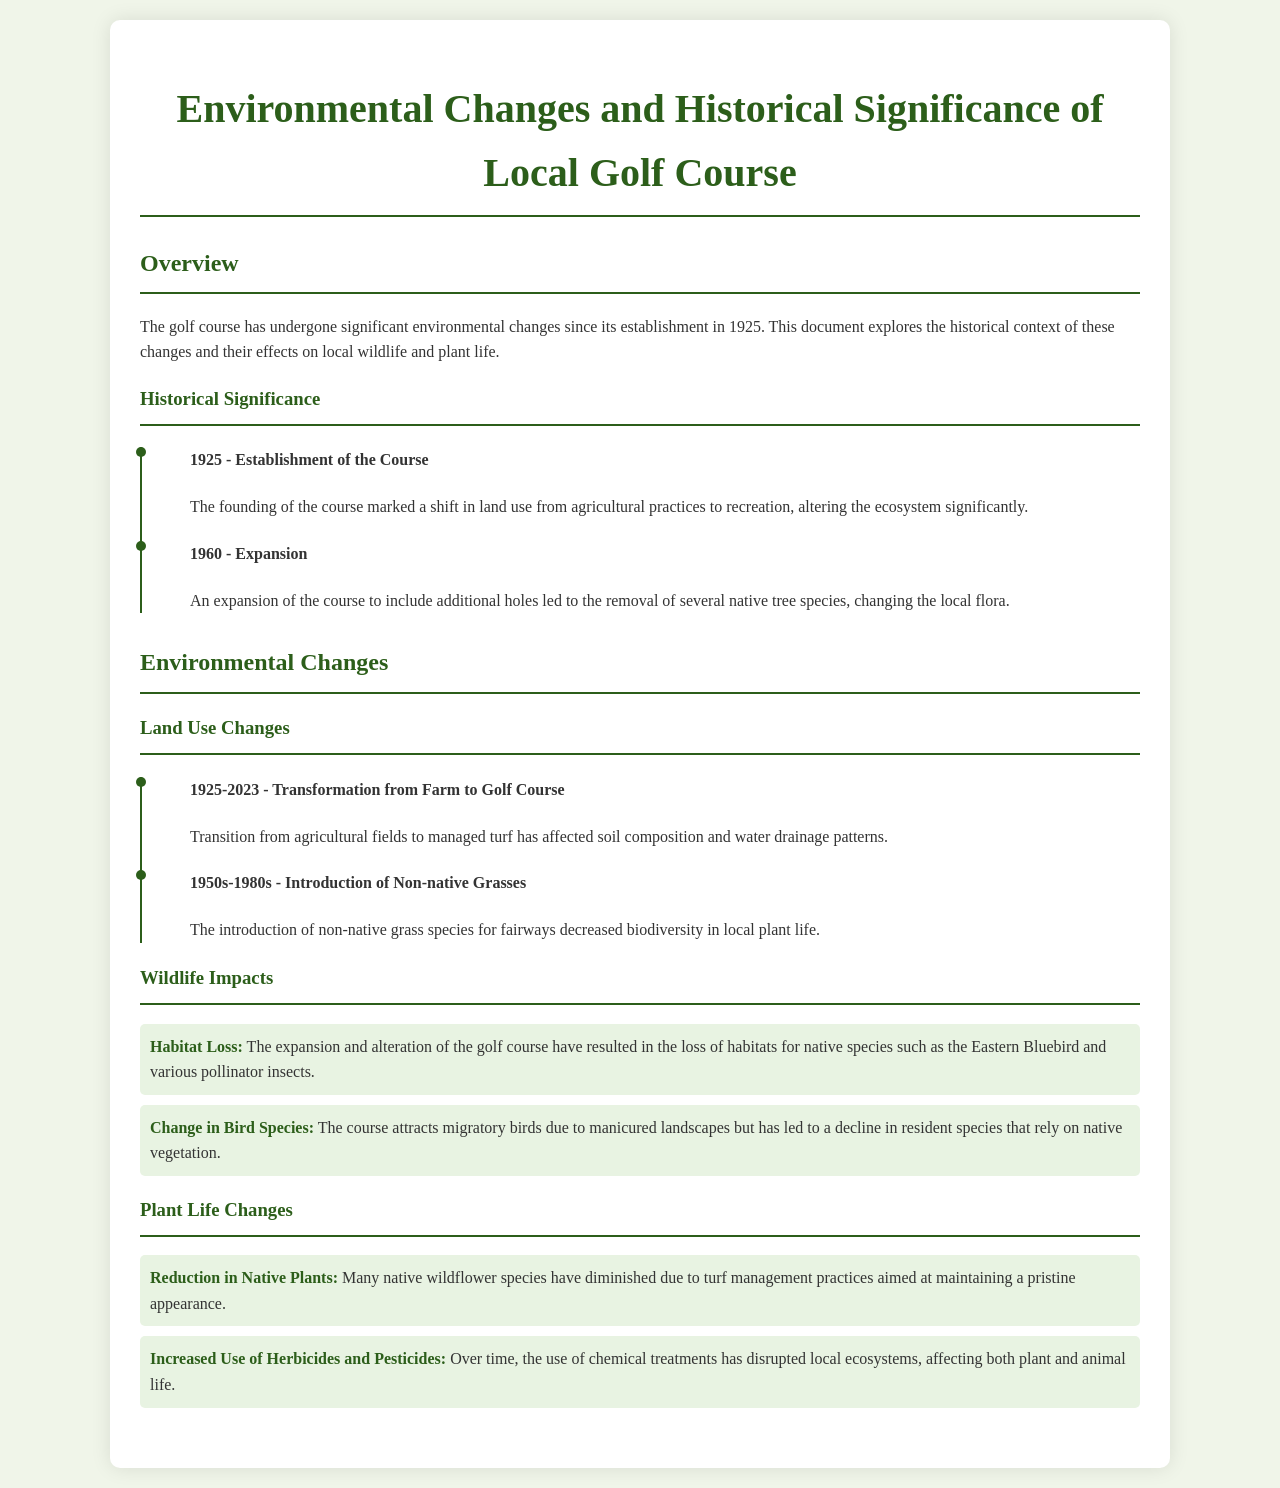What year was the golf course established? The founding of the course marks its establishment in 1925, as mentioned in the overview section.
Answer: 1925 What impact did the 1960 expansion have? The document states that the expansion led to the removal of several native tree species, indicating a change in local flora.
Answer: Removal of native trees What change occurred from 1925 to 2023? The transformation from agricultural fields to managed turf has affected soil composition and water drainage patterns over the years.
Answer: Transformation from farm to golf course What native bird species has been affected by habitat loss? The habitat loss impacts native species such as the Eastern Bluebird, as listed in the wildlife impacts section.
Answer: Eastern Bluebird What type of grasses were introduced between the 1950s and 1980s? The introduction of non-native grass species for fairways is highlighted, affecting local biodiversity.
Answer: Non-native grasses How has the use of herbicides changed plant life? The document mentions that the increased use of herbicides and pesticides has disrupted local ecosystems, affecting both plant and animal life.
Answer: Disrupted local ecosystems What was the primary purpose of the document? The document aims to explore the historical context of environmental changes and their effects on local wildlife and flora.
Answer: Historical context and effects How did the course alter the land use from its original purpose? The golf course marked a shift in land use from agricultural practices to recreation.
Answer: From agriculture to recreation 